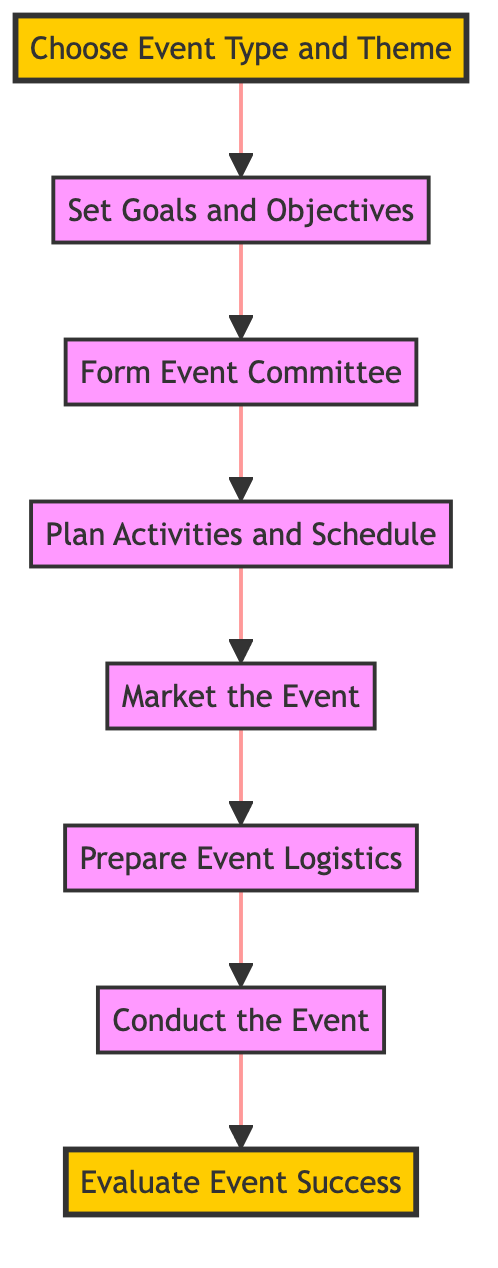What's the first step in organizing a successful school event? The diagram shows that the first step at the bottom is "Choose Event Type and Theme."
Answer: Choose Event Type and Theme How many total steps are there in the process? By counting each node in the flow chart from "Choose Event Type and Theme" to "Evaluate Event Success," we find a total of 8 steps.
Answer: 8 What is the final step in the event organization process? The last node in the flow chart at the top of the flow is "Evaluate Event Success."
Answer: Evaluate Event Success Which step comes immediately after 'Market the Event'? The flow chart connects 'Market the Event' directly to 'Prepare Event Logistics,' making it the immediate next step.
Answer: Prepare Event Logistics What is the relationship between 'Form Event Committee' and 'Set Goals and Objectives'? The flow chart shows that 'Form Event Committee' follows 'Set Goals and Objectives,' indicating a direct progression from establishing goals to assembling a team for the event.
Answer: Form Event Committee follows Set Goals and Objectives What type of feedback is collected in the last step? The final step, "Evaluate Event Success," includes collecting feedback from participants to assess the event's effectiveness.
Answer: Feedback from participants Is 'Conduct the Event' an initial or final step in the process? The position of 'Conduct the Event' in the flow chart indicates it is a central step that occurs before evaluating the success, thus it is not an initial or final step.
Answer: Neither initial nor final What step involves promoting the event? The step labeled 'Market the Event' is specifically dedicated to promoting the event through various channels.
Answer: Market the Event 